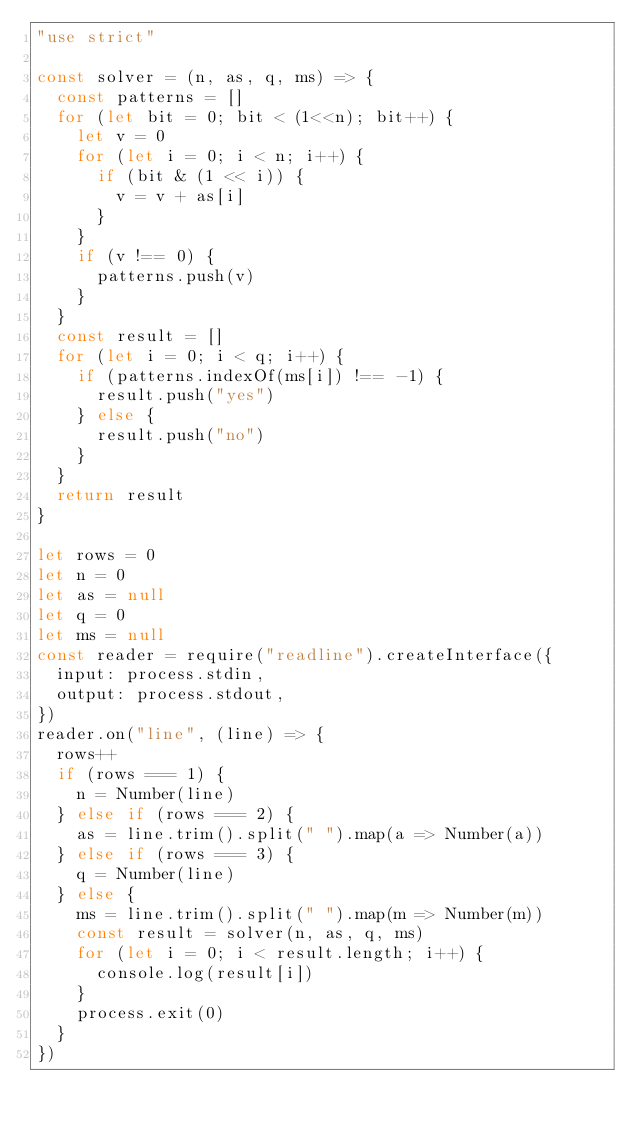<code> <loc_0><loc_0><loc_500><loc_500><_JavaScript_>"use strict"

const solver = (n, as, q, ms) => {
  const patterns = []
  for (let bit = 0; bit < (1<<n); bit++) {
    let v = 0
    for (let i = 0; i < n; i++) {
      if (bit & (1 << i)) {
        v = v + as[i]
      }
    }
    if (v !== 0) {
      patterns.push(v)
    }
  }
  const result = []
  for (let i = 0; i < q; i++) {
    if (patterns.indexOf(ms[i]) !== -1) {
      result.push("yes")
    } else {
      result.push("no")
    }
  }
  return result
}

let rows = 0
let n = 0
let as = null
let q = 0
let ms = null
const reader = require("readline").createInterface({
  input: process.stdin,
  output: process.stdout,
})
reader.on("line", (line) => {
  rows++
  if (rows === 1) {
    n = Number(line)
  } else if (rows === 2) {
    as = line.trim().split(" ").map(a => Number(a))
  } else if (rows === 3) {
    q = Number(line)
  } else {
    ms = line.trim().split(" ").map(m => Number(m))
    const result = solver(n, as, q, ms)
    for (let i = 0; i < result.length; i++) {
      console.log(result[i])
    }
    process.exit(0)
  }
})

</code> 